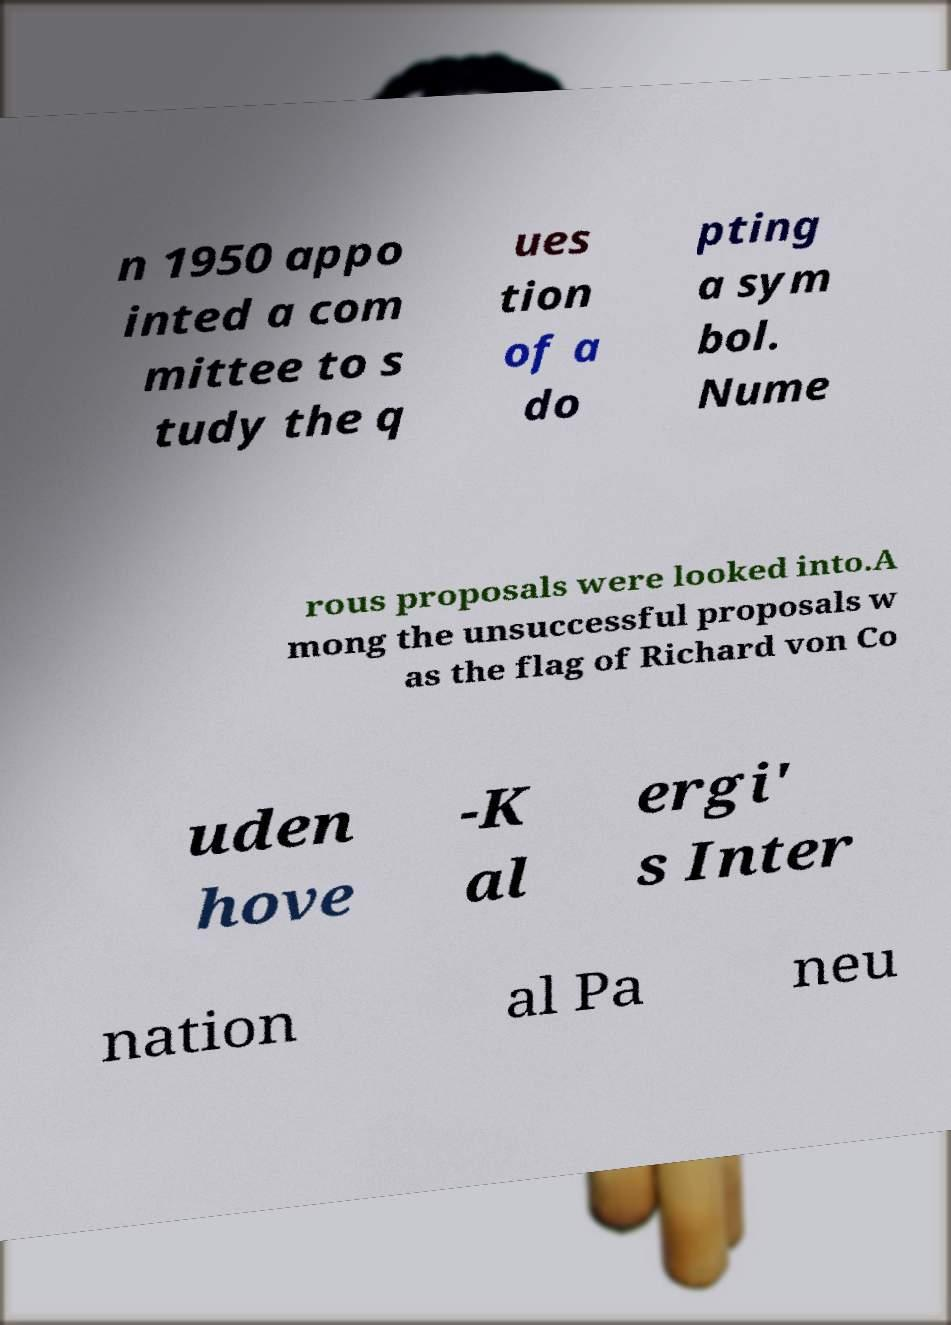For documentation purposes, I need the text within this image transcribed. Could you provide that? n 1950 appo inted a com mittee to s tudy the q ues tion of a do pting a sym bol. Nume rous proposals were looked into.A mong the unsuccessful proposals w as the flag of Richard von Co uden hove -K al ergi' s Inter nation al Pa neu 